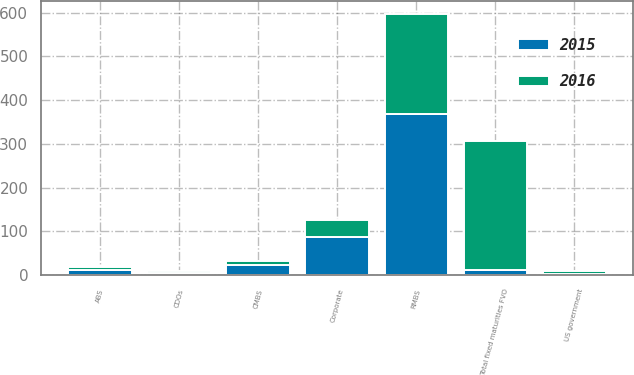Convert chart. <chart><loc_0><loc_0><loc_500><loc_500><stacked_bar_chart><ecel><fcel>ABS<fcel>CDOs<fcel>CMBS<fcel>Corporate<fcel>US government<fcel>RMBS<fcel>Total fixed maturities FVO<nl><fcel>2016<fcel>7<fcel>3<fcel>8<fcel>40<fcel>7<fcel>228<fcel>293<nl><fcel>2015<fcel>13<fcel>6<fcel>24<fcel>87<fcel>3<fcel>368<fcel>13<nl></chart> 